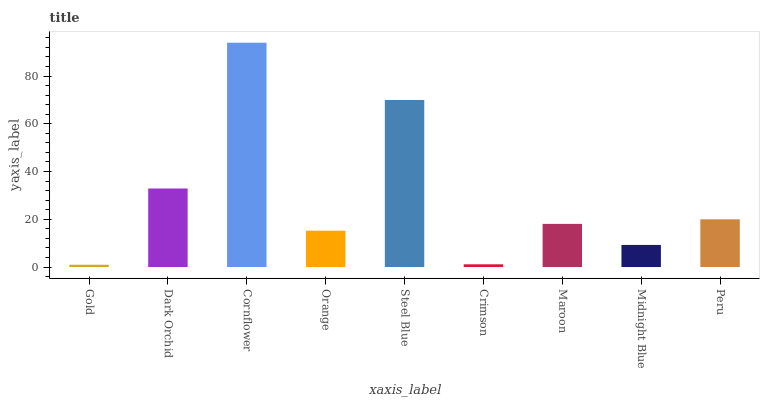Is Gold the minimum?
Answer yes or no. Yes. Is Cornflower the maximum?
Answer yes or no. Yes. Is Dark Orchid the minimum?
Answer yes or no. No. Is Dark Orchid the maximum?
Answer yes or no. No. Is Dark Orchid greater than Gold?
Answer yes or no. Yes. Is Gold less than Dark Orchid?
Answer yes or no. Yes. Is Gold greater than Dark Orchid?
Answer yes or no. No. Is Dark Orchid less than Gold?
Answer yes or no. No. Is Maroon the high median?
Answer yes or no. Yes. Is Maroon the low median?
Answer yes or no. Yes. Is Cornflower the high median?
Answer yes or no. No. Is Crimson the low median?
Answer yes or no. No. 